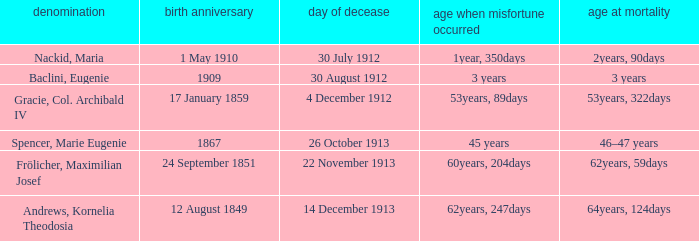What is the name of the person born in 1909? Baclini, Eugenie. 